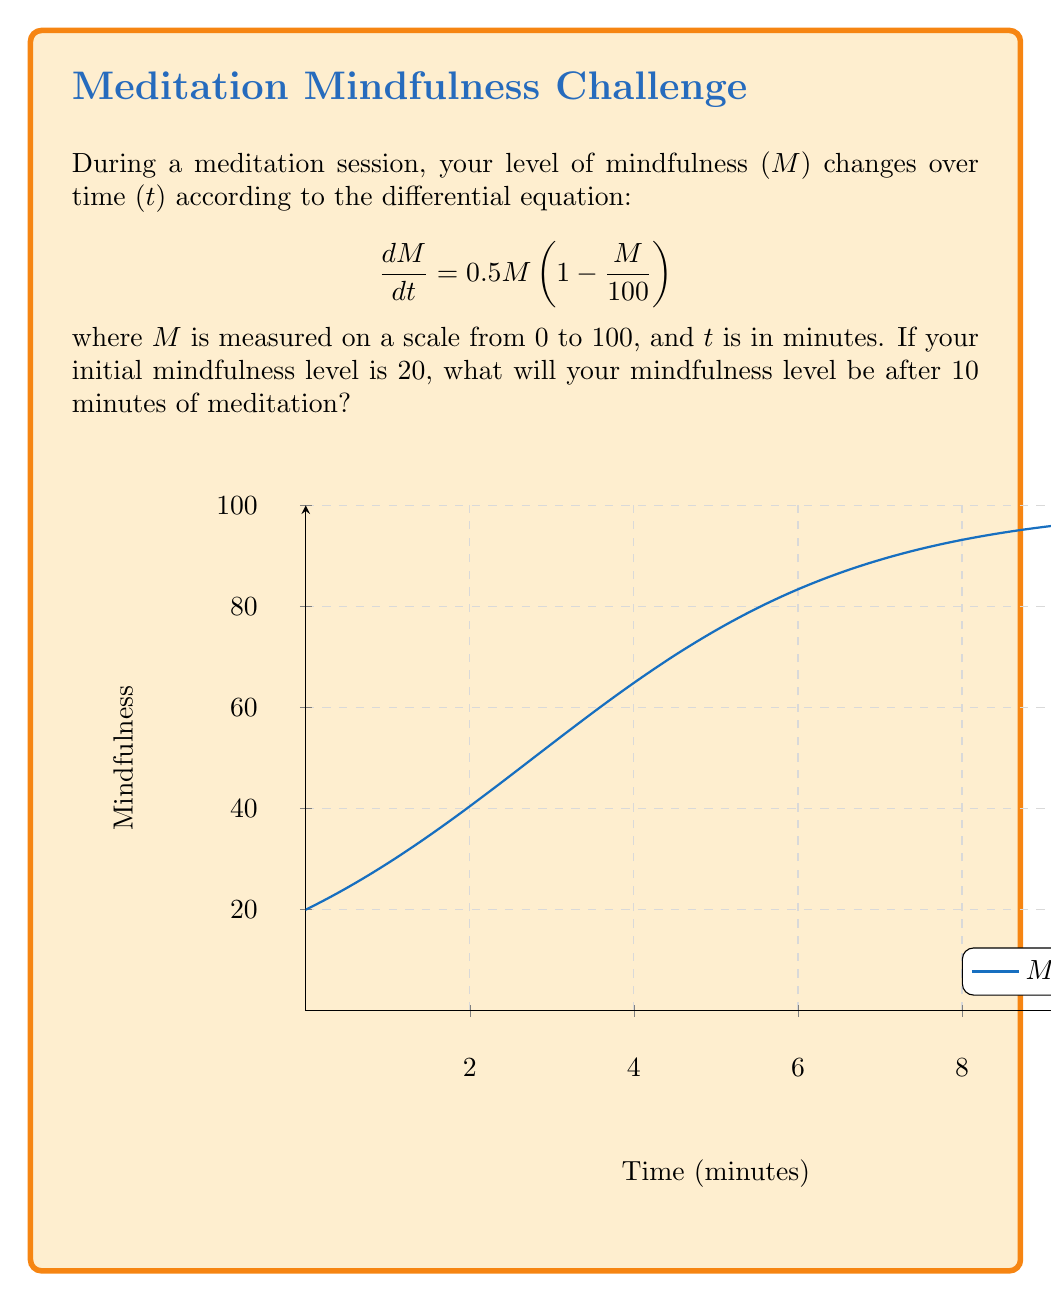Could you help me with this problem? To solve this problem, we need to follow these steps:

1) First, recognize that this is a logistic growth equation with a carrying capacity of 100.

2) The general solution for a logistic growth equation is:

   $$M(t) = \frac{K}{1 + (\frac{K}{M_0} - 1)e^{-rt}}$$

   where K is the carrying capacity, M₀ is the initial value, and r is the growth rate.

3) In this case, K = 100, M₀ = 20, and r = 0.5.

4) Substituting these values into the equation:

   $$M(t) = \frac{100}{1 + (\frac{100}{20} - 1)e^{-0.5t}}$$

5) Simplify:

   $$M(t) = \frac{100}{1 + 4e^{-0.5t}}$$

6) Now, we want to find M(10), so substitute t = 10:

   $$M(10) = \frac{100}{1 + 4e^{-0.5(10)}}$$

7) Calculate:

   $$M(10) = \frac{100}{1 + 4e^{-5}} \approx 82.26$$

Therefore, after 10 minutes of meditation, your mindfulness level will be approximately 82.26.
Answer: $M(10) \approx 82.26$ 